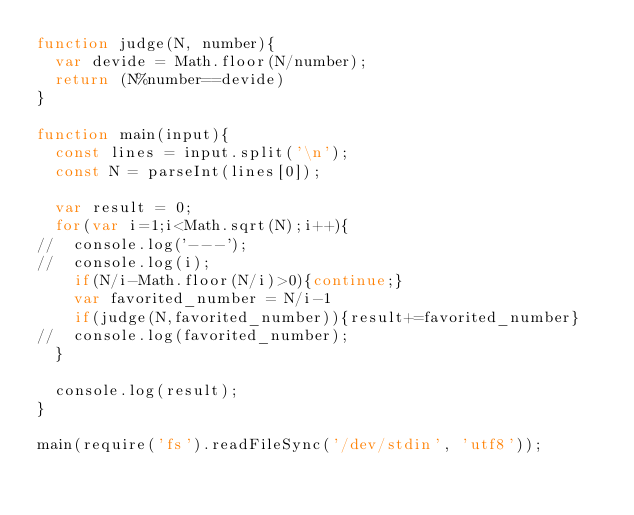Convert code to text. <code><loc_0><loc_0><loc_500><loc_500><_JavaScript_>function judge(N, number){
  var devide = Math.floor(N/number);
  return (N%number==devide)
}

function main(input){
  const lines = input.split('\n');
  const N = parseInt(lines[0]);

  var result = 0;
  for(var i=1;i<Math.sqrt(N);i++){
//  console.log('---');
//  console.log(i);
    if(N/i-Math.floor(N/i)>0){continue;}
    var favorited_number = N/i-1
    if(judge(N,favorited_number)){result+=favorited_number}
//  console.log(favorited_number);
  }

  console.log(result);
}

main(require('fs').readFileSync('/dev/stdin', 'utf8'));

</code> 